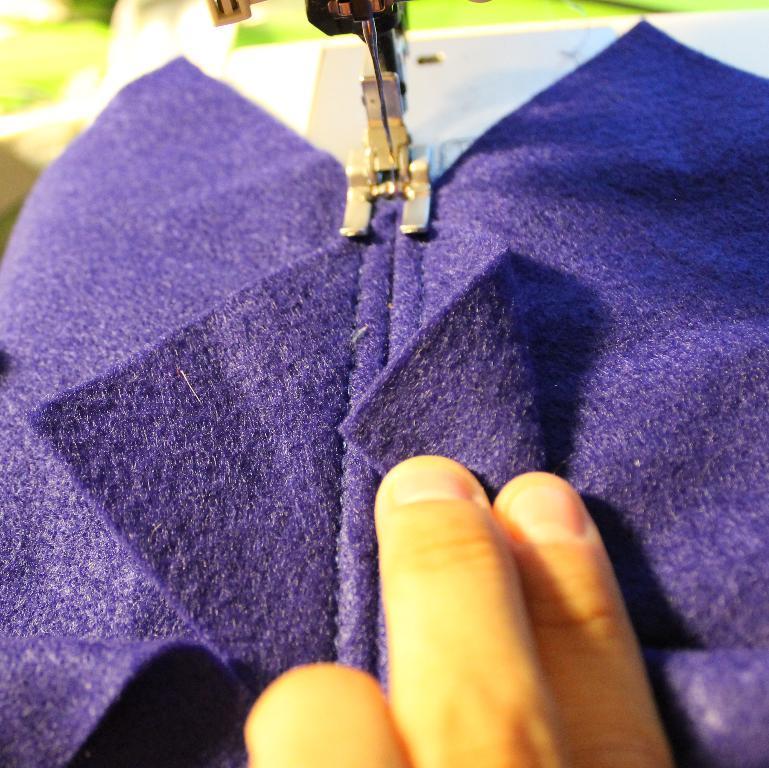Describe this image in one or two sentences. In this image we can see the fingers of a person. We can see a person stitching a cloth on the machine. There is a blur background at the top of the image. 